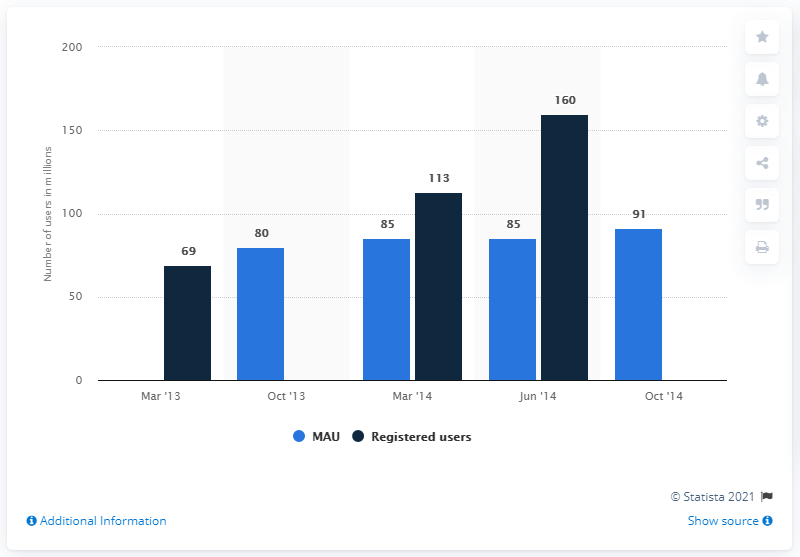Draw attention to some important aspects in this diagram. As of October 2014, BBM had 91 monthly active users. 